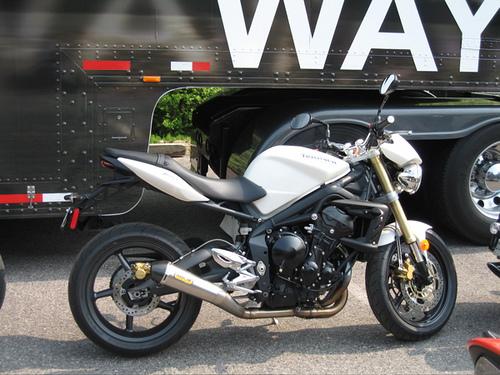What kind of motorcycle is this?
Write a very short answer. Kawasaki. Is there 1 or 2 mirrors?
Quick response, please. 2. What does the truck side say?
Short answer required. Way. 